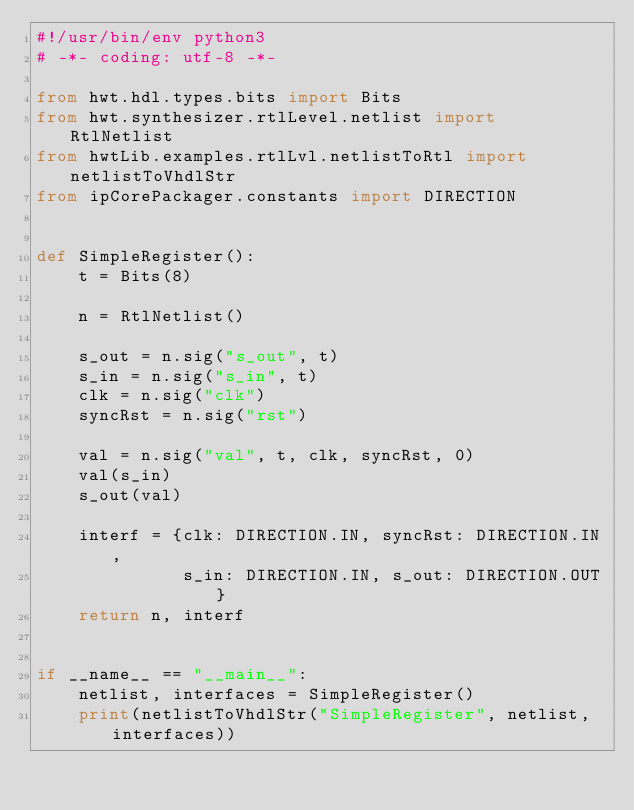<code> <loc_0><loc_0><loc_500><loc_500><_Python_>#!/usr/bin/env python3
# -*- coding: utf-8 -*-

from hwt.hdl.types.bits import Bits
from hwt.synthesizer.rtlLevel.netlist import RtlNetlist
from hwtLib.examples.rtlLvl.netlistToRtl import netlistToVhdlStr
from ipCorePackager.constants import DIRECTION


def SimpleRegister():
    t = Bits(8)

    n = RtlNetlist()

    s_out = n.sig("s_out", t)
    s_in = n.sig("s_in", t)
    clk = n.sig("clk")
    syncRst = n.sig("rst")

    val = n.sig("val", t, clk, syncRst, 0)
    val(s_in)
    s_out(val)

    interf = {clk: DIRECTION.IN, syncRst: DIRECTION.IN,
              s_in: DIRECTION.IN, s_out: DIRECTION.OUT}
    return n, interf


if __name__ == "__main__":
    netlist, interfaces = SimpleRegister()
    print(netlistToVhdlStr("SimpleRegister", netlist, interfaces))
</code> 